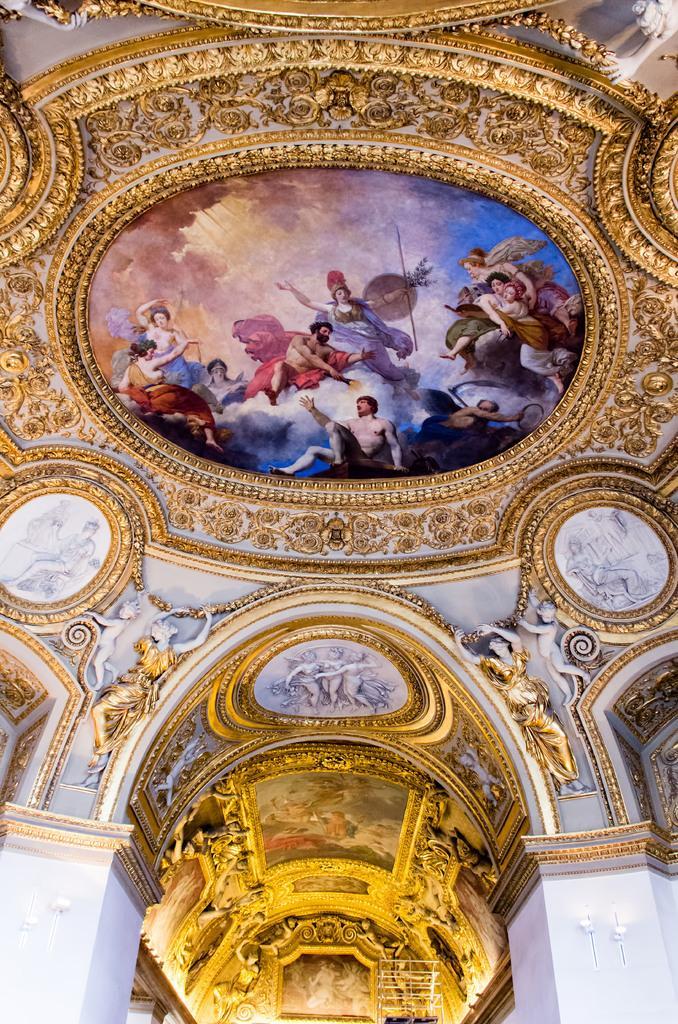Could you give a brief overview of what you see in this image? In this image I can see roof of a building and on the top of roof of building I can see painting , on the painting I can see colorful images of persons. 